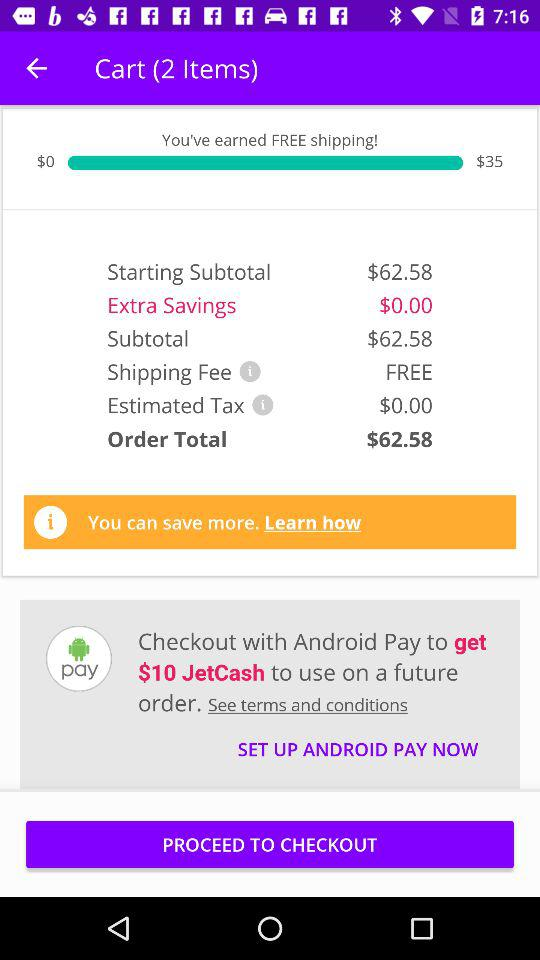What is the "Order Total"? The "Order Total" is $62.58. 